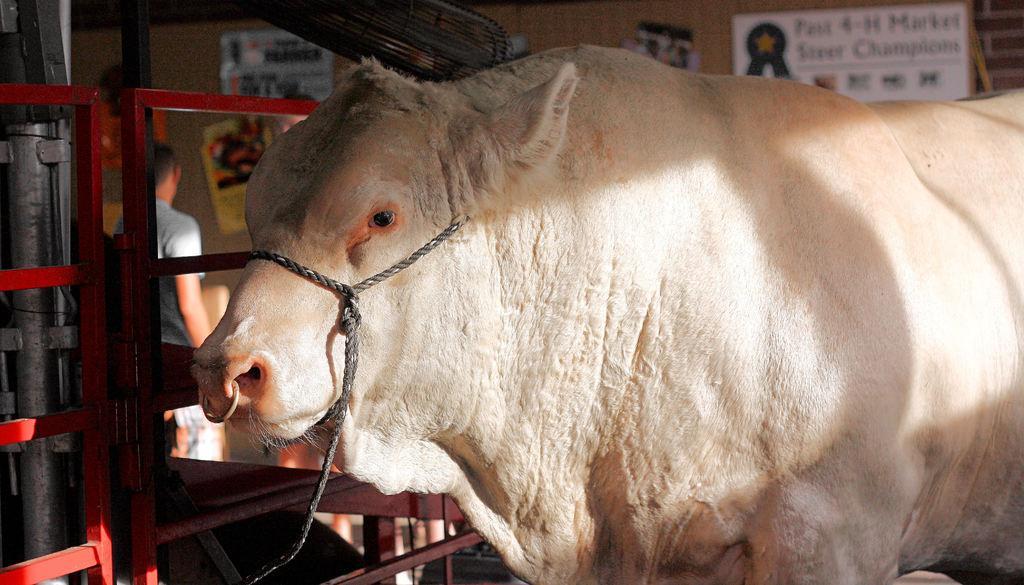Can you describe this image briefly? In this image we can see an animal, beside the animal there is an iron fence and in the background there is a person standing and a wall with posters. 